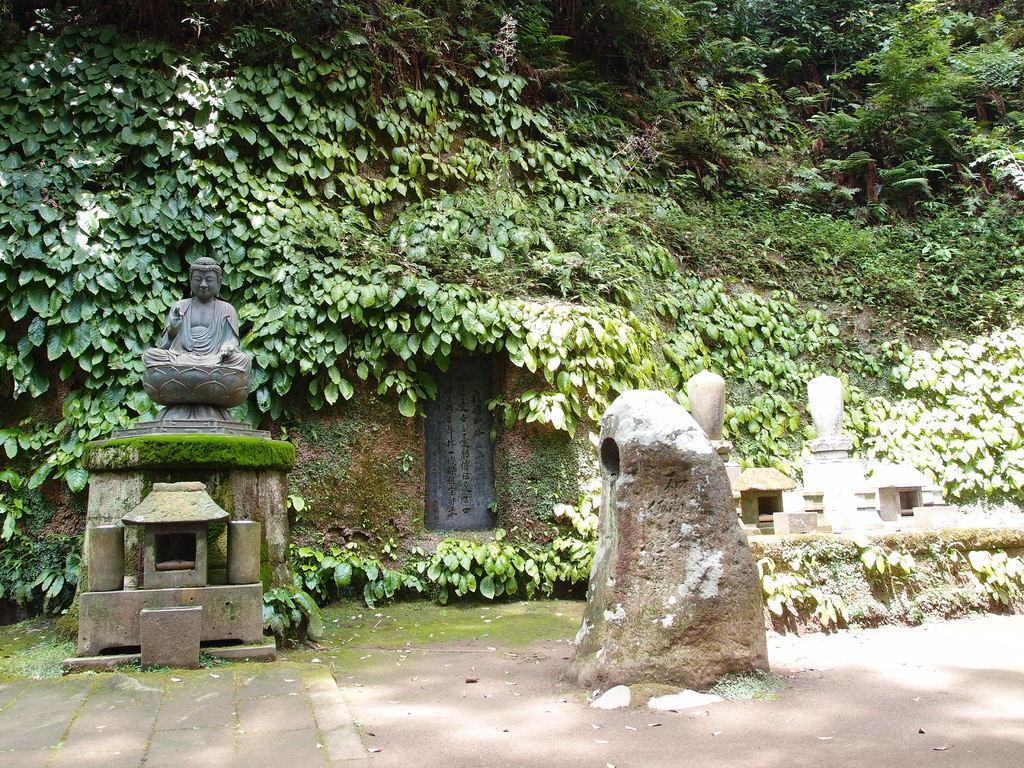In one or two sentences, can you explain what this image depicts? In this image, we can see a statue and there are some green leaves, we can see some green trees. 